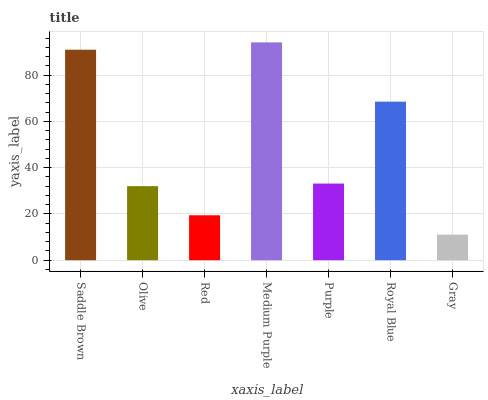Is Gray the minimum?
Answer yes or no. Yes. Is Medium Purple the maximum?
Answer yes or no. Yes. Is Olive the minimum?
Answer yes or no. No. Is Olive the maximum?
Answer yes or no. No. Is Saddle Brown greater than Olive?
Answer yes or no. Yes. Is Olive less than Saddle Brown?
Answer yes or no. Yes. Is Olive greater than Saddle Brown?
Answer yes or no. No. Is Saddle Brown less than Olive?
Answer yes or no. No. Is Purple the high median?
Answer yes or no. Yes. Is Purple the low median?
Answer yes or no. Yes. Is Royal Blue the high median?
Answer yes or no. No. Is Olive the low median?
Answer yes or no. No. 